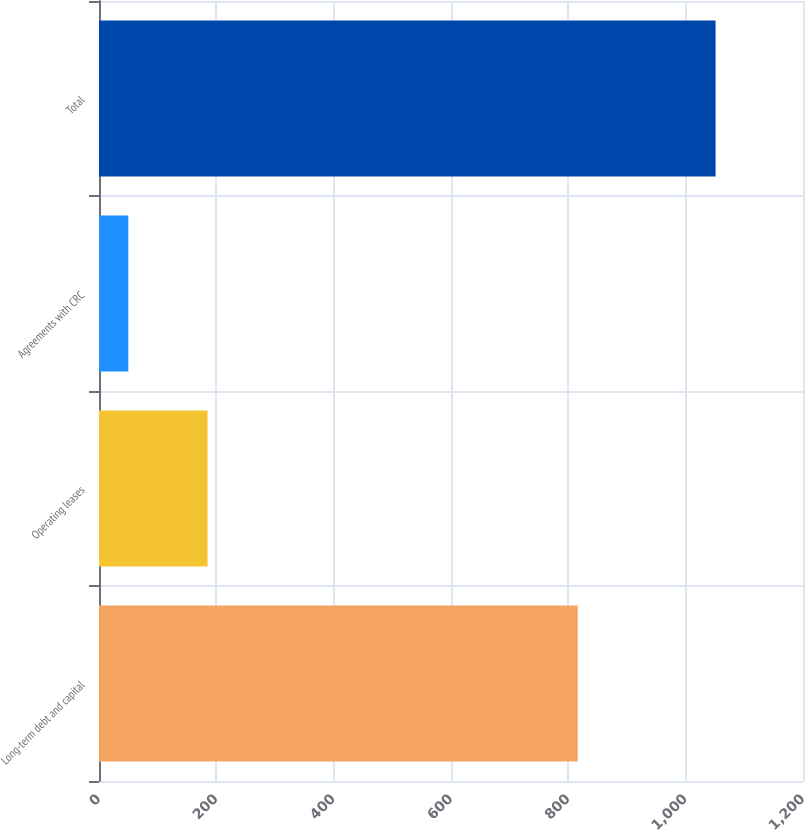<chart> <loc_0><loc_0><loc_500><loc_500><bar_chart><fcel>Long-term debt and capital<fcel>Operating leases<fcel>Agreements with CRC<fcel>Total<nl><fcel>816<fcel>185<fcel>50<fcel>1051<nl></chart> 